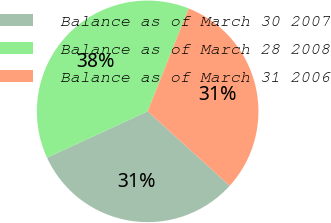<chart> <loc_0><loc_0><loc_500><loc_500><pie_chart><fcel>Balance as of March 30 2007<fcel>Balance as of March 28 2008<fcel>Balance as of March 31 2006<nl><fcel>31.41%<fcel>37.9%<fcel>30.69%<nl></chart> 